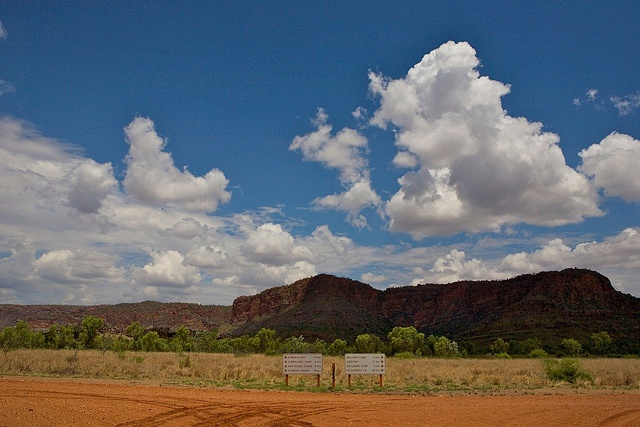Describe the objects in this image and their specific colors. I can see various objects in this image with different colors. 